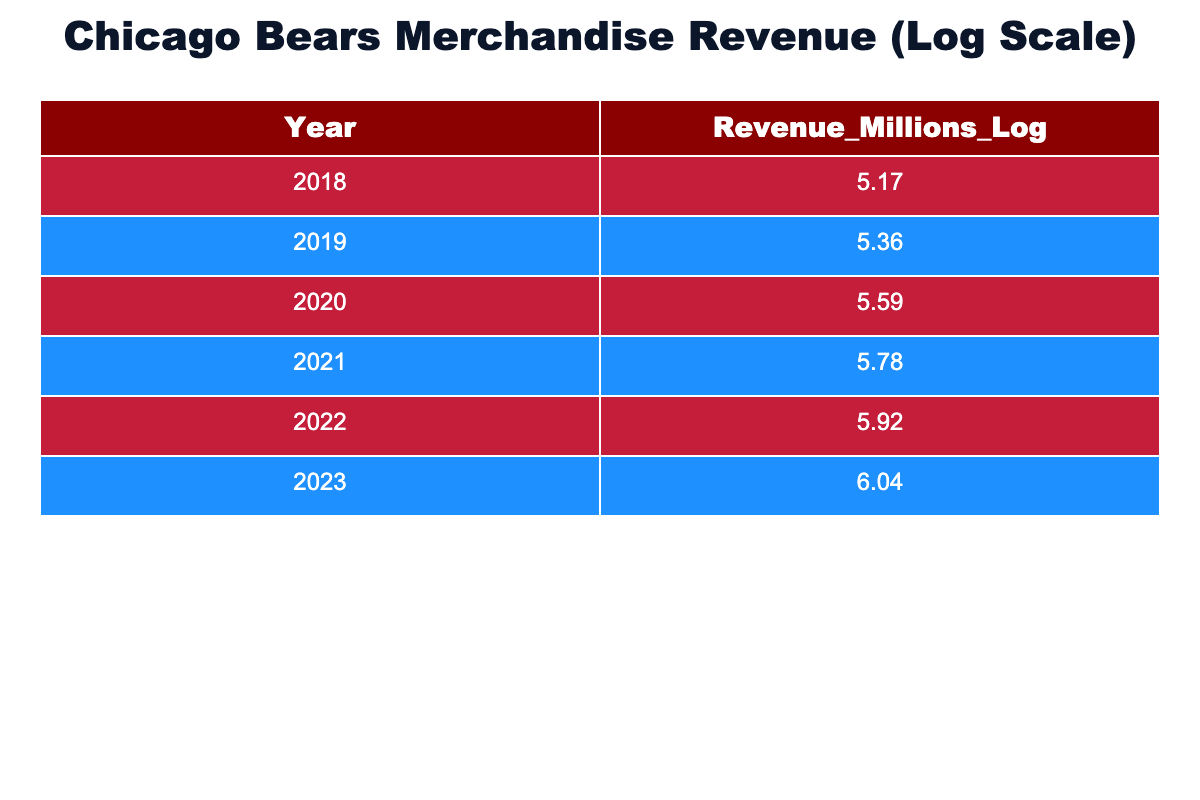What was the revenue from merchandise sales in 2020? The table shows that the revenue for 2020 is listed as 5.59 million (logarithmic value).
Answer: 5.59 million In which year did the revenue surpass 6 million in logarithmic values? Looking at the table, the revenue exceeds 6 million in logarithmic values in 2023, as the corresponding value for that year is 6.04.
Answer: 2023 What was the average revenue in logarithmic values from 2018 to 2022? To calculate the average: (5.17 + 5.36 + 5.59 + 5.78 + 5.92) / 5 = 5.564. Therefore, the average revenue from 2018 to 2022 is approximately 5.564.
Answer: 5.564 Is the revenue from merchandise sales increasing every year? By comparing the revenue values for each year in the table, we can see that each year shows an increase from the previous one, confirming that the revenue is indeed increasing every year.
Answer: Yes What was the difference in revenue between 2021 and 2019? We locate the values for 2021 (5.78) and 2019 (5.36) in the table. The difference is 5.78 - 5.36 = 0.42. Thus, the difference in revenue is 0.42 million.
Answer: 0.42 million Between which two years did the revenue increase the most? We calculate the yearly increases: 2018 to 2019 (0.19), 2019 to 2020 (0.23), 2020 to 2021 (0.19), 2021 to 2022 (0.14), and 2022 to 2023 (0.12). The largest increase is from 2019 to 2020 (0.23), making that the period of most significant growth.
Answer: 2019 to 2020 Was the revenue in 2022 more than in 2018? By examining the values in the table, the revenue for 2022 is 5.92, while for 2018 it is 5.17. Since 5.92 is greater than 5.17, it confirms that 2022's revenue was more than 2018's.
Answer: Yes What is the total revenue from 2018 to 2023? The total revenue is computed by summing the logarithmic values: 5.17 + 5.36 + 5.59 + 5.78 + 5.92 + 6.04 = 33.86. Therefore, the total revenue over these years is 33.86 million.
Answer: 33.86 million 